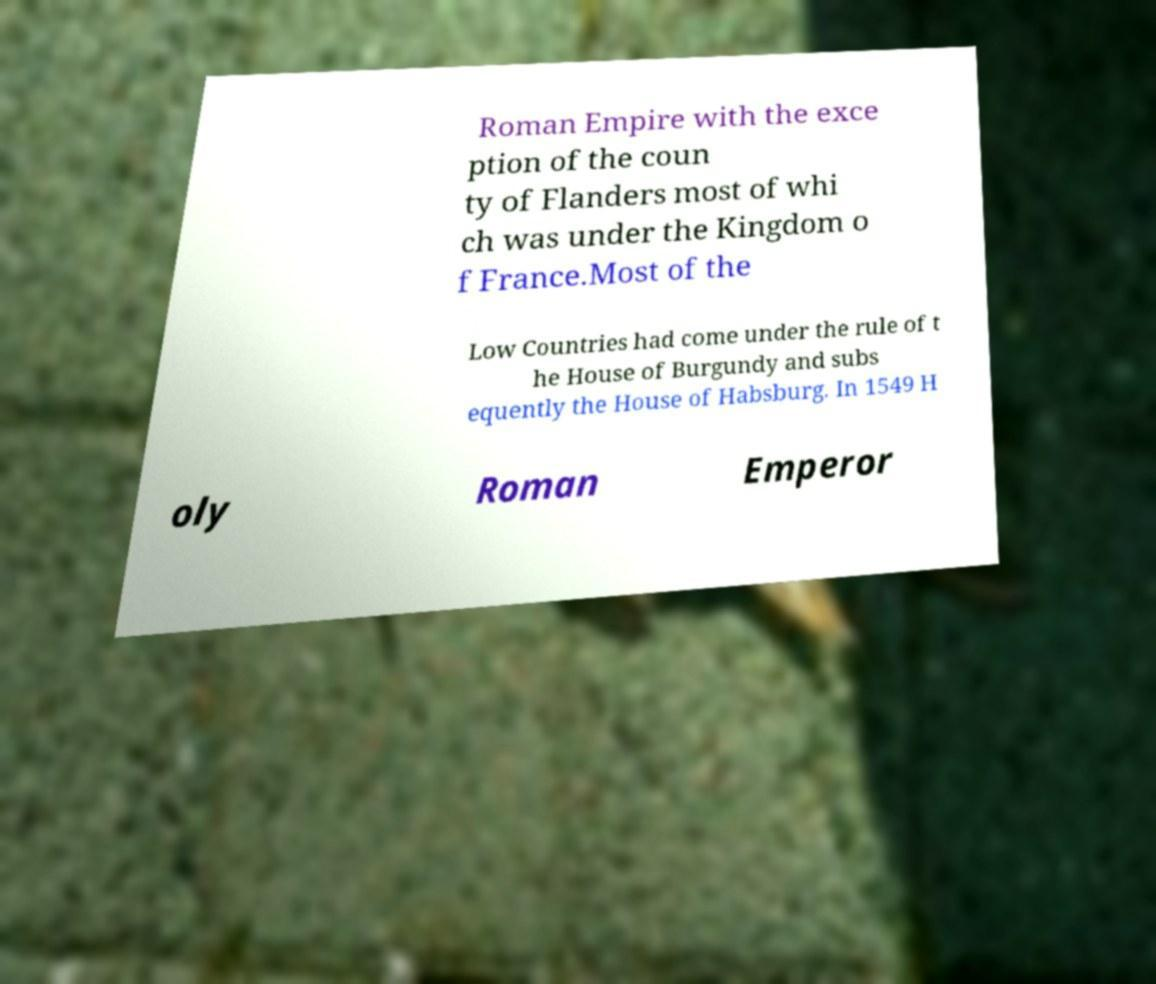For documentation purposes, I need the text within this image transcribed. Could you provide that? Roman Empire with the exce ption of the coun ty of Flanders most of whi ch was under the Kingdom o f France.Most of the Low Countries had come under the rule of t he House of Burgundy and subs equently the House of Habsburg. In 1549 H oly Roman Emperor 